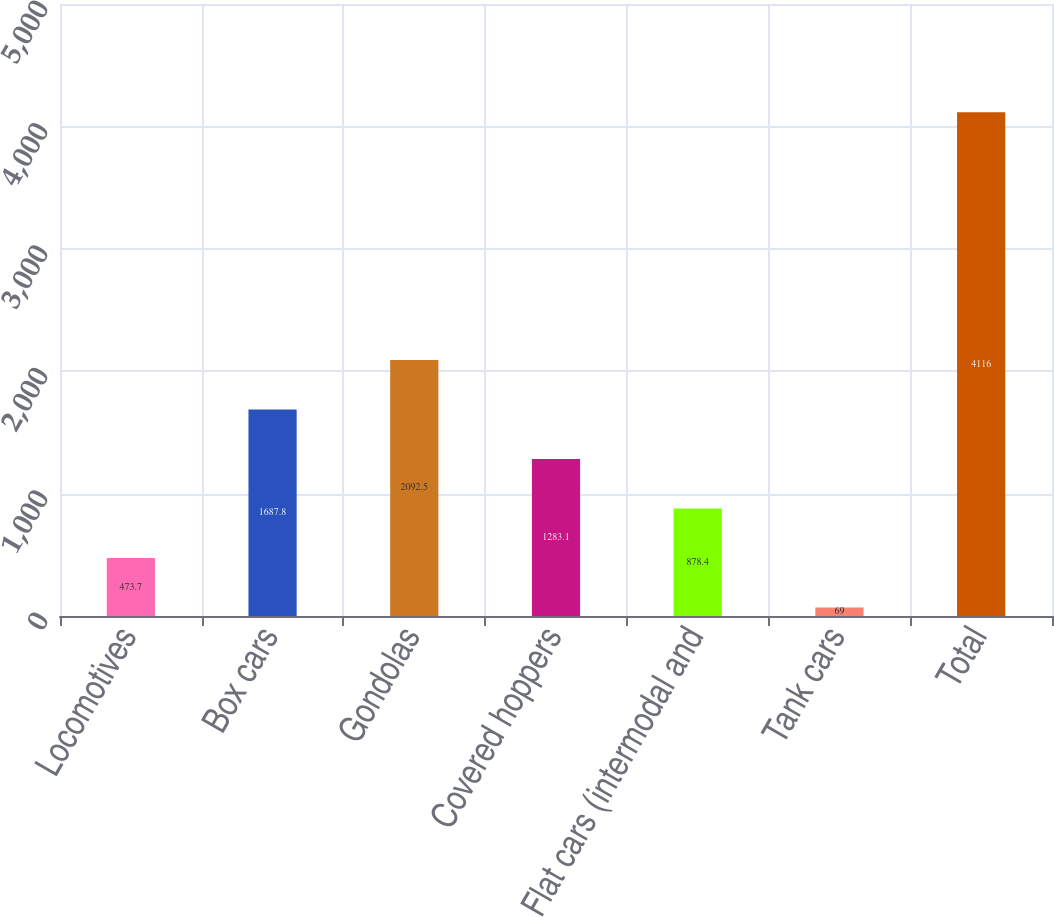Convert chart to OTSL. <chart><loc_0><loc_0><loc_500><loc_500><bar_chart><fcel>Locomotives<fcel>Box cars<fcel>Gondolas<fcel>Covered hoppers<fcel>Flat cars (intermodal and<fcel>Tank cars<fcel>Total<nl><fcel>473.7<fcel>1687.8<fcel>2092.5<fcel>1283.1<fcel>878.4<fcel>69<fcel>4116<nl></chart> 